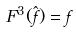Convert formula to latex. <formula><loc_0><loc_0><loc_500><loc_500>F ^ { 3 } ( \hat { f } ) = f</formula> 